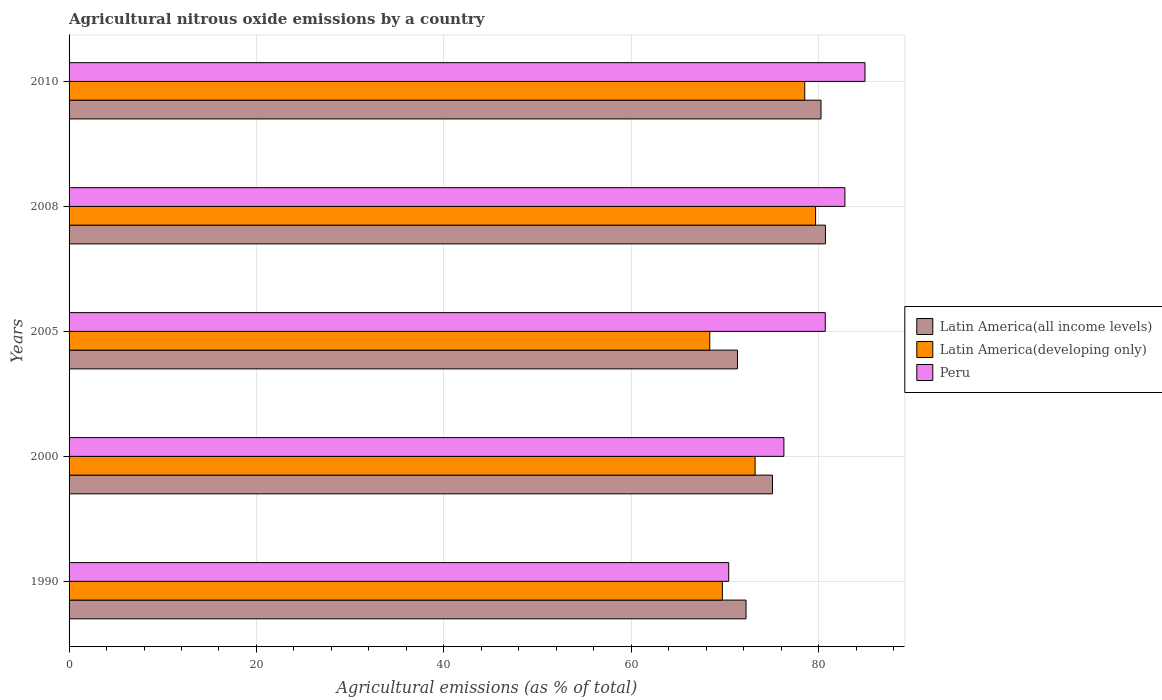How many groups of bars are there?
Give a very brief answer. 5. Are the number of bars on each tick of the Y-axis equal?
Your response must be concise. Yes. How many bars are there on the 3rd tick from the top?
Make the answer very short. 3. How many bars are there on the 1st tick from the bottom?
Give a very brief answer. 3. In how many cases, is the number of bars for a given year not equal to the number of legend labels?
Give a very brief answer. 0. What is the amount of agricultural nitrous oxide emitted in Latin America(all income levels) in 1990?
Give a very brief answer. 72.26. Across all years, what is the maximum amount of agricultural nitrous oxide emitted in Latin America(developing only)?
Your answer should be very brief. 79.68. Across all years, what is the minimum amount of agricultural nitrous oxide emitted in Latin America(all income levels)?
Provide a succinct answer. 71.34. In which year was the amount of agricultural nitrous oxide emitted in Latin America(developing only) maximum?
Give a very brief answer. 2008. In which year was the amount of agricultural nitrous oxide emitted in Latin America(developing only) minimum?
Ensure brevity in your answer.  2005. What is the total amount of agricultural nitrous oxide emitted in Peru in the graph?
Offer a very short reply. 395.17. What is the difference between the amount of agricultural nitrous oxide emitted in Latin America(developing only) in 2008 and that in 2010?
Provide a short and direct response. 1.16. What is the difference between the amount of agricultural nitrous oxide emitted in Peru in 1990 and the amount of agricultural nitrous oxide emitted in Latin America(developing only) in 2005?
Give a very brief answer. 2.02. What is the average amount of agricultural nitrous oxide emitted in Latin America(all income levels) per year?
Ensure brevity in your answer.  75.93. In the year 2010, what is the difference between the amount of agricultural nitrous oxide emitted in Latin America(all income levels) and amount of agricultural nitrous oxide emitted in Latin America(developing only)?
Provide a short and direct response. 1.74. In how many years, is the amount of agricultural nitrous oxide emitted in Latin America(developing only) greater than 72 %?
Your answer should be very brief. 3. What is the ratio of the amount of agricultural nitrous oxide emitted in Latin America(developing only) in 1990 to that in 2005?
Give a very brief answer. 1.02. What is the difference between the highest and the second highest amount of agricultural nitrous oxide emitted in Peru?
Offer a terse response. 2.14. What is the difference between the highest and the lowest amount of agricultural nitrous oxide emitted in Latin America(all income levels)?
Give a very brief answer. 9.39. In how many years, is the amount of agricultural nitrous oxide emitted in Latin America(all income levels) greater than the average amount of agricultural nitrous oxide emitted in Latin America(all income levels) taken over all years?
Make the answer very short. 2. What does the 2nd bar from the bottom in 2000 represents?
Your answer should be compact. Latin America(developing only). How many bars are there?
Provide a short and direct response. 15. Are all the bars in the graph horizontal?
Make the answer very short. Yes. Are the values on the major ticks of X-axis written in scientific E-notation?
Make the answer very short. No. Does the graph contain any zero values?
Provide a short and direct response. No. Does the graph contain grids?
Give a very brief answer. Yes. Where does the legend appear in the graph?
Provide a short and direct response. Center right. How many legend labels are there?
Provide a short and direct response. 3. How are the legend labels stacked?
Provide a succinct answer. Vertical. What is the title of the graph?
Keep it short and to the point. Agricultural nitrous oxide emissions by a country. What is the label or title of the X-axis?
Ensure brevity in your answer.  Agricultural emissions (as % of total). What is the Agricultural emissions (as % of total) of Latin America(all income levels) in 1990?
Offer a terse response. 72.26. What is the Agricultural emissions (as % of total) of Latin America(developing only) in 1990?
Offer a terse response. 69.73. What is the Agricultural emissions (as % of total) in Peru in 1990?
Keep it short and to the point. 70.41. What is the Agricultural emissions (as % of total) in Latin America(all income levels) in 2000?
Keep it short and to the point. 75.08. What is the Agricultural emissions (as % of total) of Latin America(developing only) in 2000?
Provide a short and direct response. 73.22. What is the Agricultural emissions (as % of total) in Peru in 2000?
Make the answer very short. 76.3. What is the Agricultural emissions (as % of total) of Latin America(all income levels) in 2005?
Your answer should be very brief. 71.34. What is the Agricultural emissions (as % of total) of Latin America(developing only) in 2005?
Give a very brief answer. 68.38. What is the Agricultural emissions (as % of total) in Peru in 2005?
Keep it short and to the point. 80.71. What is the Agricultural emissions (as % of total) of Latin America(all income levels) in 2008?
Your answer should be compact. 80.73. What is the Agricultural emissions (as % of total) in Latin America(developing only) in 2008?
Your answer should be very brief. 79.68. What is the Agricultural emissions (as % of total) of Peru in 2008?
Make the answer very short. 82.81. What is the Agricultural emissions (as % of total) in Latin America(all income levels) in 2010?
Provide a short and direct response. 80.26. What is the Agricultural emissions (as % of total) of Latin America(developing only) in 2010?
Your answer should be very brief. 78.52. What is the Agricultural emissions (as % of total) of Peru in 2010?
Offer a terse response. 84.95. Across all years, what is the maximum Agricultural emissions (as % of total) in Latin America(all income levels)?
Provide a succinct answer. 80.73. Across all years, what is the maximum Agricultural emissions (as % of total) in Latin America(developing only)?
Your answer should be very brief. 79.68. Across all years, what is the maximum Agricultural emissions (as % of total) of Peru?
Your answer should be very brief. 84.95. Across all years, what is the minimum Agricultural emissions (as % of total) of Latin America(all income levels)?
Offer a very short reply. 71.34. Across all years, what is the minimum Agricultural emissions (as % of total) of Latin America(developing only)?
Your answer should be compact. 68.38. Across all years, what is the minimum Agricultural emissions (as % of total) of Peru?
Offer a terse response. 70.41. What is the total Agricultural emissions (as % of total) of Latin America(all income levels) in the graph?
Offer a terse response. 379.66. What is the total Agricultural emissions (as % of total) of Latin America(developing only) in the graph?
Your answer should be very brief. 369.54. What is the total Agricultural emissions (as % of total) in Peru in the graph?
Give a very brief answer. 395.17. What is the difference between the Agricultural emissions (as % of total) in Latin America(all income levels) in 1990 and that in 2000?
Your answer should be very brief. -2.82. What is the difference between the Agricultural emissions (as % of total) of Latin America(developing only) in 1990 and that in 2000?
Offer a very short reply. -3.49. What is the difference between the Agricultural emissions (as % of total) in Peru in 1990 and that in 2000?
Give a very brief answer. -5.89. What is the difference between the Agricultural emissions (as % of total) in Latin America(all income levels) in 1990 and that in 2005?
Your answer should be compact. 0.91. What is the difference between the Agricultural emissions (as % of total) in Latin America(developing only) in 1990 and that in 2005?
Provide a short and direct response. 1.35. What is the difference between the Agricultural emissions (as % of total) in Peru in 1990 and that in 2005?
Provide a succinct answer. -10.3. What is the difference between the Agricultural emissions (as % of total) of Latin America(all income levels) in 1990 and that in 2008?
Ensure brevity in your answer.  -8.47. What is the difference between the Agricultural emissions (as % of total) of Latin America(developing only) in 1990 and that in 2008?
Your answer should be compact. -9.95. What is the difference between the Agricultural emissions (as % of total) of Peru in 1990 and that in 2008?
Your response must be concise. -12.4. What is the difference between the Agricultural emissions (as % of total) of Latin America(all income levels) in 1990 and that in 2010?
Your answer should be very brief. -8. What is the difference between the Agricultural emissions (as % of total) in Latin America(developing only) in 1990 and that in 2010?
Your answer should be compact. -8.79. What is the difference between the Agricultural emissions (as % of total) in Peru in 1990 and that in 2010?
Offer a terse response. -14.54. What is the difference between the Agricultural emissions (as % of total) in Latin America(all income levels) in 2000 and that in 2005?
Make the answer very short. 3.74. What is the difference between the Agricultural emissions (as % of total) of Latin America(developing only) in 2000 and that in 2005?
Your answer should be very brief. 4.84. What is the difference between the Agricultural emissions (as % of total) in Peru in 2000 and that in 2005?
Offer a terse response. -4.41. What is the difference between the Agricultural emissions (as % of total) of Latin America(all income levels) in 2000 and that in 2008?
Offer a terse response. -5.65. What is the difference between the Agricultural emissions (as % of total) of Latin America(developing only) in 2000 and that in 2008?
Make the answer very short. -6.46. What is the difference between the Agricultural emissions (as % of total) in Peru in 2000 and that in 2008?
Keep it short and to the point. -6.51. What is the difference between the Agricultural emissions (as % of total) of Latin America(all income levels) in 2000 and that in 2010?
Provide a short and direct response. -5.18. What is the difference between the Agricultural emissions (as % of total) of Latin America(developing only) in 2000 and that in 2010?
Ensure brevity in your answer.  -5.3. What is the difference between the Agricultural emissions (as % of total) in Peru in 2000 and that in 2010?
Ensure brevity in your answer.  -8.65. What is the difference between the Agricultural emissions (as % of total) in Latin America(all income levels) in 2005 and that in 2008?
Offer a terse response. -9.39. What is the difference between the Agricultural emissions (as % of total) in Latin America(developing only) in 2005 and that in 2008?
Ensure brevity in your answer.  -11.3. What is the difference between the Agricultural emissions (as % of total) in Peru in 2005 and that in 2008?
Ensure brevity in your answer.  -2.1. What is the difference between the Agricultural emissions (as % of total) in Latin America(all income levels) in 2005 and that in 2010?
Your answer should be compact. -8.92. What is the difference between the Agricultural emissions (as % of total) of Latin America(developing only) in 2005 and that in 2010?
Give a very brief answer. -10.14. What is the difference between the Agricultural emissions (as % of total) in Peru in 2005 and that in 2010?
Keep it short and to the point. -4.24. What is the difference between the Agricultural emissions (as % of total) of Latin America(all income levels) in 2008 and that in 2010?
Your response must be concise. 0.47. What is the difference between the Agricultural emissions (as % of total) of Latin America(developing only) in 2008 and that in 2010?
Give a very brief answer. 1.16. What is the difference between the Agricultural emissions (as % of total) in Peru in 2008 and that in 2010?
Offer a terse response. -2.14. What is the difference between the Agricultural emissions (as % of total) in Latin America(all income levels) in 1990 and the Agricultural emissions (as % of total) in Latin America(developing only) in 2000?
Your response must be concise. -0.97. What is the difference between the Agricultural emissions (as % of total) of Latin America(all income levels) in 1990 and the Agricultural emissions (as % of total) of Peru in 2000?
Your response must be concise. -4.04. What is the difference between the Agricultural emissions (as % of total) of Latin America(developing only) in 1990 and the Agricultural emissions (as % of total) of Peru in 2000?
Provide a succinct answer. -6.57. What is the difference between the Agricultural emissions (as % of total) in Latin America(all income levels) in 1990 and the Agricultural emissions (as % of total) in Latin America(developing only) in 2005?
Give a very brief answer. 3.87. What is the difference between the Agricultural emissions (as % of total) of Latin America(all income levels) in 1990 and the Agricultural emissions (as % of total) of Peru in 2005?
Provide a short and direct response. -8.46. What is the difference between the Agricultural emissions (as % of total) in Latin America(developing only) in 1990 and the Agricultural emissions (as % of total) in Peru in 2005?
Keep it short and to the point. -10.98. What is the difference between the Agricultural emissions (as % of total) of Latin America(all income levels) in 1990 and the Agricultural emissions (as % of total) of Latin America(developing only) in 2008?
Your answer should be very brief. -7.42. What is the difference between the Agricultural emissions (as % of total) in Latin America(all income levels) in 1990 and the Agricultural emissions (as % of total) in Peru in 2008?
Your response must be concise. -10.55. What is the difference between the Agricultural emissions (as % of total) in Latin America(developing only) in 1990 and the Agricultural emissions (as % of total) in Peru in 2008?
Offer a very short reply. -13.08. What is the difference between the Agricultural emissions (as % of total) in Latin America(all income levels) in 1990 and the Agricultural emissions (as % of total) in Latin America(developing only) in 2010?
Your response must be concise. -6.27. What is the difference between the Agricultural emissions (as % of total) of Latin America(all income levels) in 1990 and the Agricultural emissions (as % of total) of Peru in 2010?
Your answer should be compact. -12.7. What is the difference between the Agricultural emissions (as % of total) of Latin America(developing only) in 1990 and the Agricultural emissions (as % of total) of Peru in 2010?
Your answer should be compact. -15.22. What is the difference between the Agricultural emissions (as % of total) of Latin America(all income levels) in 2000 and the Agricultural emissions (as % of total) of Latin America(developing only) in 2005?
Ensure brevity in your answer.  6.69. What is the difference between the Agricultural emissions (as % of total) in Latin America(all income levels) in 2000 and the Agricultural emissions (as % of total) in Peru in 2005?
Make the answer very short. -5.63. What is the difference between the Agricultural emissions (as % of total) in Latin America(developing only) in 2000 and the Agricultural emissions (as % of total) in Peru in 2005?
Your answer should be very brief. -7.49. What is the difference between the Agricultural emissions (as % of total) in Latin America(all income levels) in 2000 and the Agricultural emissions (as % of total) in Latin America(developing only) in 2008?
Keep it short and to the point. -4.6. What is the difference between the Agricultural emissions (as % of total) of Latin America(all income levels) in 2000 and the Agricultural emissions (as % of total) of Peru in 2008?
Offer a very short reply. -7.73. What is the difference between the Agricultural emissions (as % of total) of Latin America(developing only) in 2000 and the Agricultural emissions (as % of total) of Peru in 2008?
Your answer should be compact. -9.59. What is the difference between the Agricultural emissions (as % of total) of Latin America(all income levels) in 2000 and the Agricultural emissions (as % of total) of Latin America(developing only) in 2010?
Provide a succinct answer. -3.44. What is the difference between the Agricultural emissions (as % of total) of Latin America(all income levels) in 2000 and the Agricultural emissions (as % of total) of Peru in 2010?
Your response must be concise. -9.87. What is the difference between the Agricultural emissions (as % of total) in Latin America(developing only) in 2000 and the Agricultural emissions (as % of total) in Peru in 2010?
Give a very brief answer. -11.73. What is the difference between the Agricultural emissions (as % of total) in Latin America(all income levels) in 2005 and the Agricultural emissions (as % of total) in Latin America(developing only) in 2008?
Ensure brevity in your answer.  -8.34. What is the difference between the Agricultural emissions (as % of total) of Latin America(all income levels) in 2005 and the Agricultural emissions (as % of total) of Peru in 2008?
Ensure brevity in your answer.  -11.47. What is the difference between the Agricultural emissions (as % of total) of Latin America(developing only) in 2005 and the Agricultural emissions (as % of total) of Peru in 2008?
Provide a succinct answer. -14.42. What is the difference between the Agricultural emissions (as % of total) of Latin America(all income levels) in 2005 and the Agricultural emissions (as % of total) of Latin America(developing only) in 2010?
Provide a short and direct response. -7.18. What is the difference between the Agricultural emissions (as % of total) in Latin America(all income levels) in 2005 and the Agricultural emissions (as % of total) in Peru in 2010?
Keep it short and to the point. -13.61. What is the difference between the Agricultural emissions (as % of total) in Latin America(developing only) in 2005 and the Agricultural emissions (as % of total) in Peru in 2010?
Your answer should be compact. -16.57. What is the difference between the Agricultural emissions (as % of total) in Latin America(all income levels) in 2008 and the Agricultural emissions (as % of total) in Latin America(developing only) in 2010?
Provide a short and direct response. 2.21. What is the difference between the Agricultural emissions (as % of total) in Latin America(all income levels) in 2008 and the Agricultural emissions (as % of total) in Peru in 2010?
Your response must be concise. -4.22. What is the difference between the Agricultural emissions (as % of total) in Latin America(developing only) in 2008 and the Agricultural emissions (as % of total) in Peru in 2010?
Ensure brevity in your answer.  -5.27. What is the average Agricultural emissions (as % of total) of Latin America(all income levels) per year?
Give a very brief answer. 75.93. What is the average Agricultural emissions (as % of total) in Latin America(developing only) per year?
Offer a terse response. 73.91. What is the average Agricultural emissions (as % of total) in Peru per year?
Provide a short and direct response. 79.03. In the year 1990, what is the difference between the Agricultural emissions (as % of total) in Latin America(all income levels) and Agricultural emissions (as % of total) in Latin America(developing only)?
Ensure brevity in your answer.  2.53. In the year 1990, what is the difference between the Agricultural emissions (as % of total) of Latin America(all income levels) and Agricultural emissions (as % of total) of Peru?
Keep it short and to the point. 1.85. In the year 1990, what is the difference between the Agricultural emissions (as % of total) of Latin America(developing only) and Agricultural emissions (as % of total) of Peru?
Your answer should be compact. -0.68. In the year 2000, what is the difference between the Agricultural emissions (as % of total) in Latin America(all income levels) and Agricultural emissions (as % of total) in Latin America(developing only)?
Keep it short and to the point. 1.86. In the year 2000, what is the difference between the Agricultural emissions (as % of total) in Latin America(all income levels) and Agricultural emissions (as % of total) in Peru?
Your response must be concise. -1.22. In the year 2000, what is the difference between the Agricultural emissions (as % of total) in Latin America(developing only) and Agricultural emissions (as % of total) in Peru?
Ensure brevity in your answer.  -3.07. In the year 2005, what is the difference between the Agricultural emissions (as % of total) of Latin America(all income levels) and Agricultural emissions (as % of total) of Latin America(developing only)?
Offer a terse response. 2.96. In the year 2005, what is the difference between the Agricultural emissions (as % of total) of Latin America(all income levels) and Agricultural emissions (as % of total) of Peru?
Keep it short and to the point. -9.37. In the year 2005, what is the difference between the Agricultural emissions (as % of total) of Latin America(developing only) and Agricultural emissions (as % of total) of Peru?
Make the answer very short. -12.33. In the year 2008, what is the difference between the Agricultural emissions (as % of total) in Latin America(all income levels) and Agricultural emissions (as % of total) in Latin America(developing only)?
Make the answer very short. 1.05. In the year 2008, what is the difference between the Agricultural emissions (as % of total) in Latin America(all income levels) and Agricultural emissions (as % of total) in Peru?
Provide a short and direct response. -2.08. In the year 2008, what is the difference between the Agricultural emissions (as % of total) in Latin America(developing only) and Agricultural emissions (as % of total) in Peru?
Provide a succinct answer. -3.13. In the year 2010, what is the difference between the Agricultural emissions (as % of total) of Latin America(all income levels) and Agricultural emissions (as % of total) of Latin America(developing only)?
Provide a short and direct response. 1.74. In the year 2010, what is the difference between the Agricultural emissions (as % of total) in Latin America(all income levels) and Agricultural emissions (as % of total) in Peru?
Give a very brief answer. -4.69. In the year 2010, what is the difference between the Agricultural emissions (as % of total) in Latin America(developing only) and Agricultural emissions (as % of total) in Peru?
Provide a succinct answer. -6.43. What is the ratio of the Agricultural emissions (as % of total) of Latin America(all income levels) in 1990 to that in 2000?
Offer a terse response. 0.96. What is the ratio of the Agricultural emissions (as % of total) of Latin America(developing only) in 1990 to that in 2000?
Provide a succinct answer. 0.95. What is the ratio of the Agricultural emissions (as % of total) in Peru in 1990 to that in 2000?
Ensure brevity in your answer.  0.92. What is the ratio of the Agricultural emissions (as % of total) of Latin America(all income levels) in 1990 to that in 2005?
Keep it short and to the point. 1.01. What is the ratio of the Agricultural emissions (as % of total) of Latin America(developing only) in 1990 to that in 2005?
Offer a very short reply. 1.02. What is the ratio of the Agricultural emissions (as % of total) of Peru in 1990 to that in 2005?
Keep it short and to the point. 0.87. What is the ratio of the Agricultural emissions (as % of total) of Latin America(all income levels) in 1990 to that in 2008?
Keep it short and to the point. 0.9. What is the ratio of the Agricultural emissions (as % of total) in Latin America(developing only) in 1990 to that in 2008?
Keep it short and to the point. 0.88. What is the ratio of the Agricultural emissions (as % of total) in Peru in 1990 to that in 2008?
Provide a short and direct response. 0.85. What is the ratio of the Agricultural emissions (as % of total) in Latin America(all income levels) in 1990 to that in 2010?
Provide a short and direct response. 0.9. What is the ratio of the Agricultural emissions (as % of total) in Latin America(developing only) in 1990 to that in 2010?
Make the answer very short. 0.89. What is the ratio of the Agricultural emissions (as % of total) of Peru in 1990 to that in 2010?
Your response must be concise. 0.83. What is the ratio of the Agricultural emissions (as % of total) in Latin America(all income levels) in 2000 to that in 2005?
Provide a succinct answer. 1.05. What is the ratio of the Agricultural emissions (as % of total) of Latin America(developing only) in 2000 to that in 2005?
Your answer should be compact. 1.07. What is the ratio of the Agricultural emissions (as % of total) in Peru in 2000 to that in 2005?
Offer a very short reply. 0.95. What is the ratio of the Agricultural emissions (as % of total) of Latin America(developing only) in 2000 to that in 2008?
Provide a succinct answer. 0.92. What is the ratio of the Agricultural emissions (as % of total) in Peru in 2000 to that in 2008?
Provide a succinct answer. 0.92. What is the ratio of the Agricultural emissions (as % of total) in Latin America(all income levels) in 2000 to that in 2010?
Ensure brevity in your answer.  0.94. What is the ratio of the Agricultural emissions (as % of total) of Latin America(developing only) in 2000 to that in 2010?
Offer a terse response. 0.93. What is the ratio of the Agricultural emissions (as % of total) in Peru in 2000 to that in 2010?
Give a very brief answer. 0.9. What is the ratio of the Agricultural emissions (as % of total) in Latin America(all income levels) in 2005 to that in 2008?
Provide a short and direct response. 0.88. What is the ratio of the Agricultural emissions (as % of total) of Latin America(developing only) in 2005 to that in 2008?
Offer a very short reply. 0.86. What is the ratio of the Agricultural emissions (as % of total) of Peru in 2005 to that in 2008?
Provide a succinct answer. 0.97. What is the ratio of the Agricultural emissions (as % of total) in Latin America(all income levels) in 2005 to that in 2010?
Offer a terse response. 0.89. What is the ratio of the Agricultural emissions (as % of total) of Latin America(developing only) in 2005 to that in 2010?
Provide a succinct answer. 0.87. What is the ratio of the Agricultural emissions (as % of total) of Peru in 2005 to that in 2010?
Provide a short and direct response. 0.95. What is the ratio of the Agricultural emissions (as % of total) in Latin America(all income levels) in 2008 to that in 2010?
Your answer should be very brief. 1.01. What is the ratio of the Agricultural emissions (as % of total) in Latin America(developing only) in 2008 to that in 2010?
Your response must be concise. 1.01. What is the ratio of the Agricultural emissions (as % of total) in Peru in 2008 to that in 2010?
Your answer should be very brief. 0.97. What is the difference between the highest and the second highest Agricultural emissions (as % of total) of Latin America(all income levels)?
Offer a terse response. 0.47. What is the difference between the highest and the second highest Agricultural emissions (as % of total) of Latin America(developing only)?
Give a very brief answer. 1.16. What is the difference between the highest and the second highest Agricultural emissions (as % of total) of Peru?
Your answer should be compact. 2.14. What is the difference between the highest and the lowest Agricultural emissions (as % of total) in Latin America(all income levels)?
Provide a succinct answer. 9.39. What is the difference between the highest and the lowest Agricultural emissions (as % of total) of Latin America(developing only)?
Make the answer very short. 11.3. What is the difference between the highest and the lowest Agricultural emissions (as % of total) of Peru?
Your answer should be very brief. 14.54. 